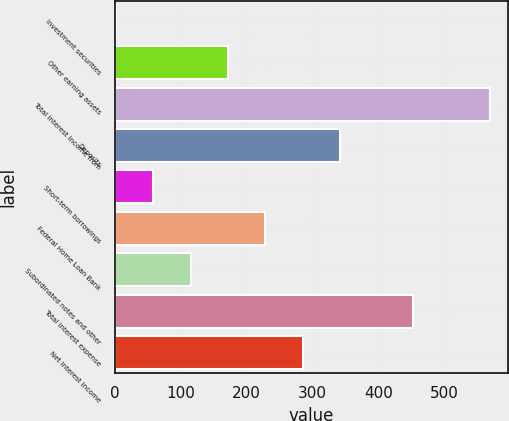Convert chart. <chart><loc_0><loc_0><loc_500><loc_500><bar_chart><fcel>Investment securities<fcel>Other earning assets<fcel>Total interest income from<fcel>Deposits<fcel>Short-term borrowings<fcel>Federal Home Loan Bank<fcel>Subordinated notes and other<fcel>Total interest expense<fcel>Net interest income<nl><fcel>1.9<fcel>172<fcel>568.9<fcel>342.1<fcel>58.6<fcel>228.7<fcel>115.3<fcel>452.7<fcel>285.4<nl></chart> 